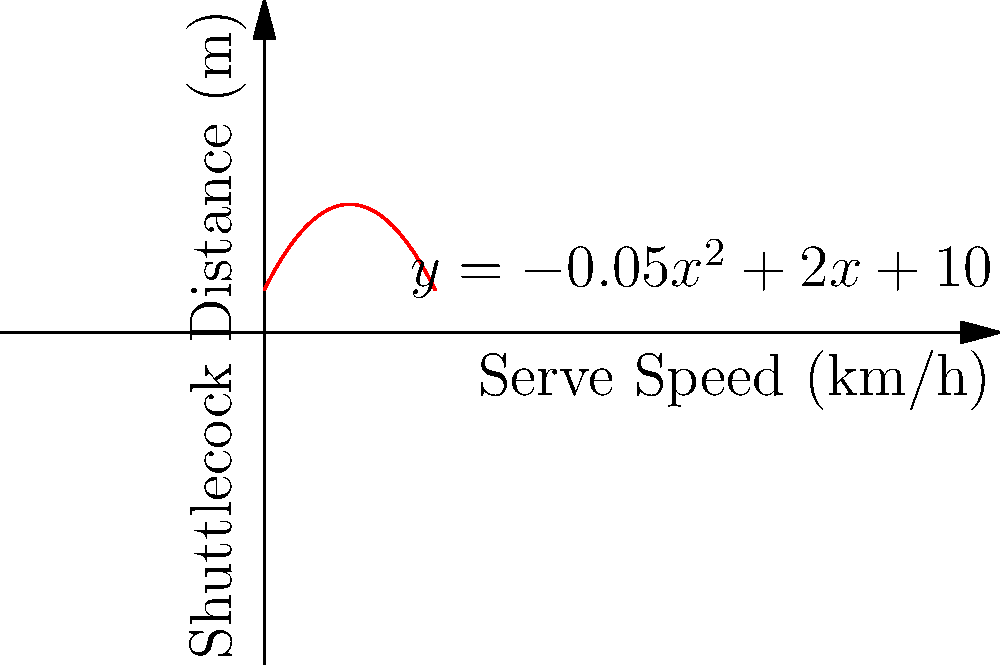In a badminton match, a player's serve speed affects the distance the shuttlecock travels. The relationship between serve speed (x) in km/h and shuttlecock distance (y) in meters is modeled by the quadratic equation $y = -0.05x^2 + 2x + 10$. At what serve speed will the shuttlecock travel the maximum distance, and what is that maximum distance? To find the maximum distance and the corresponding serve speed:

1. The quadratic equation is in the form $y = ax^2 + bx + c$, where:
   $a = -0.05$, $b = 2$, and $c = 10$

2. For a quadratic function, the x-coordinate of the vertex represents the value where y is maximum. It's given by the formula: $x = -\frac{b}{2a}$

3. Substituting the values:
   $x = -\frac{2}{2(-0.05)} = -\frac{2}{-0.1} = 20$

4. The serve speed for maximum distance is 20 km/h.

5. To find the maximum distance, substitute x = 20 into the original equation:
   $y = -0.05(20)^2 + 2(20) + 10$
   $y = -0.05(400) + 40 + 10$
   $y = -20 + 40 + 10 = 30$

6. The maximum distance is 30 meters.
Answer: 20 km/h; 30 meters 